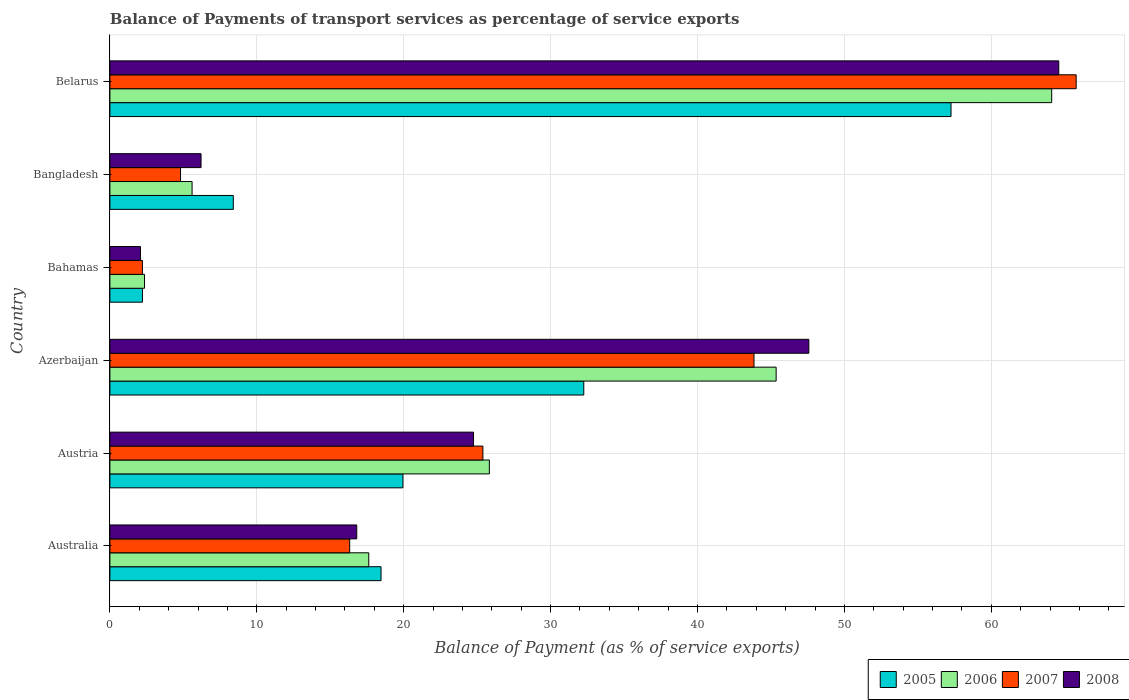How many different coloured bars are there?
Your answer should be compact. 4. How many groups of bars are there?
Ensure brevity in your answer.  6. Are the number of bars per tick equal to the number of legend labels?
Your answer should be compact. Yes. Are the number of bars on each tick of the Y-axis equal?
Your answer should be very brief. Yes. How many bars are there on the 5th tick from the top?
Make the answer very short. 4. How many bars are there on the 3rd tick from the bottom?
Make the answer very short. 4. What is the label of the 3rd group of bars from the top?
Your answer should be very brief. Bahamas. In how many cases, is the number of bars for a given country not equal to the number of legend labels?
Keep it short and to the point. 0. What is the balance of payments of transport services in 2008 in Azerbaijan?
Keep it short and to the point. 47.58. Across all countries, what is the maximum balance of payments of transport services in 2008?
Provide a succinct answer. 64.6. Across all countries, what is the minimum balance of payments of transport services in 2007?
Your answer should be very brief. 2.21. In which country was the balance of payments of transport services in 2008 maximum?
Ensure brevity in your answer.  Belarus. In which country was the balance of payments of transport services in 2006 minimum?
Your answer should be very brief. Bahamas. What is the total balance of payments of transport services in 2008 in the graph?
Provide a succinct answer. 162.02. What is the difference between the balance of payments of transport services in 2006 in Australia and that in Belarus?
Offer a very short reply. -46.49. What is the difference between the balance of payments of transport services in 2008 in Azerbaijan and the balance of payments of transport services in 2005 in Australia?
Your answer should be very brief. 29.12. What is the average balance of payments of transport services in 2008 per country?
Your answer should be compact. 27. What is the difference between the balance of payments of transport services in 2006 and balance of payments of transport services in 2007 in Bangladesh?
Offer a terse response. 0.79. In how many countries, is the balance of payments of transport services in 2005 greater than 60 %?
Offer a very short reply. 0. What is the ratio of the balance of payments of transport services in 2008 in Australia to that in Austria?
Provide a succinct answer. 0.68. What is the difference between the highest and the second highest balance of payments of transport services in 2007?
Give a very brief answer. 21.93. What is the difference between the highest and the lowest balance of payments of transport services in 2005?
Your response must be concise. 55.04. In how many countries, is the balance of payments of transport services in 2008 greater than the average balance of payments of transport services in 2008 taken over all countries?
Offer a very short reply. 2. Is the sum of the balance of payments of transport services in 2006 in Australia and Azerbaijan greater than the maximum balance of payments of transport services in 2005 across all countries?
Ensure brevity in your answer.  Yes. Is it the case that in every country, the sum of the balance of payments of transport services in 2005 and balance of payments of transport services in 2006 is greater than the sum of balance of payments of transport services in 2008 and balance of payments of transport services in 2007?
Your answer should be very brief. No. Is it the case that in every country, the sum of the balance of payments of transport services in 2006 and balance of payments of transport services in 2007 is greater than the balance of payments of transport services in 2008?
Offer a very short reply. Yes. How many bars are there?
Keep it short and to the point. 24. Are all the bars in the graph horizontal?
Your response must be concise. Yes. What is the difference between two consecutive major ticks on the X-axis?
Offer a very short reply. 10. Are the values on the major ticks of X-axis written in scientific E-notation?
Your answer should be very brief. No. Does the graph contain any zero values?
Give a very brief answer. No. Does the graph contain grids?
Your answer should be very brief. Yes. Where does the legend appear in the graph?
Give a very brief answer. Bottom right. What is the title of the graph?
Your answer should be compact. Balance of Payments of transport services as percentage of service exports. Does "1989" appear as one of the legend labels in the graph?
Offer a very short reply. No. What is the label or title of the X-axis?
Give a very brief answer. Balance of Payment (as % of service exports). What is the Balance of Payment (as % of service exports) in 2005 in Australia?
Your answer should be compact. 18.46. What is the Balance of Payment (as % of service exports) of 2006 in Australia?
Your response must be concise. 17.62. What is the Balance of Payment (as % of service exports) in 2007 in Australia?
Ensure brevity in your answer.  16.32. What is the Balance of Payment (as % of service exports) in 2008 in Australia?
Provide a succinct answer. 16.81. What is the Balance of Payment (as % of service exports) in 2005 in Austria?
Your answer should be compact. 19.95. What is the Balance of Payment (as % of service exports) in 2006 in Austria?
Provide a succinct answer. 25.83. What is the Balance of Payment (as % of service exports) in 2007 in Austria?
Provide a succinct answer. 25.39. What is the Balance of Payment (as % of service exports) of 2008 in Austria?
Keep it short and to the point. 24.75. What is the Balance of Payment (as % of service exports) of 2005 in Azerbaijan?
Provide a short and direct response. 32.26. What is the Balance of Payment (as % of service exports) of 2006 in Azerbaijan?
Give a very brief answer. 45.35. What is the Balance of Payment (as % of service exports) of 2007 in Azerbaijan?
Your answer should be very brief. 43.85. What is the Balance of Payment (as % of service exports) in 2008 in Azerbaijan?
Your answer should be compact. 47.58. What is the Balance of Payment (as % of service exports) of 2005 in Bahamas?
Your response must be concise. 2.22. What is the Balance of Payment (as % of service exports) in 2006 in Bahamas?
Give a very brief answer. 2.36. What is the Balance of Payment (as % of service exports) of 2007 in Bahamas?
Give a very brief answer. 2.21. What is the Balance of Payment (as % of service exports) of 2008 in Bahamas?
Provide a succinct answer. 2.08. What is the Balance of Payment (as % of service exports) of 2005 in Bangladesh?
Your answer should be compact. 8.4. What is the Balance of Payment (as % of service exports) of 2006 in Bangladesh?
Offer a terse response. 5.6. What is the Balance of Payment (as % of service exports) of 2007 in Bangladesh?
Your answer should be very brief. 4.81. What is the Balance of Payment (as % of service exports) of 2008 in Bangladesh?
Your response must be concise. 6.21. What is the Balance of Payment (as % of service exports) in 2005 in Belarus?
Offer a terse response. 57.26. What is the Balance of Payment (as % of service exports) of 2006 in Belarus?
Your answer should be compact. 64.11. What is the Balance of Payment (as % of service exports) of 2007 in Belarus?
Give a very brief answer. 65.78. What is the Balance of Payment (as % of service exports) in 2008 in Belarus?
Give a very brief answer. 64.6. Across all countries, what is the maximum Balance of Payment (as % of service exports) in 2005?
Offer a terse response. 57.26. Across all countries, what is the maximum Balance of Payment (as % of service exports) in 2006?
Your response must be concise. 64.11. Across all countries, what is the maximum Balance of Payment (as % of service exports) of 2007?
Your answer should be very brief. 65.78. Across all countries, what is the maximum Balance of Payment (as % of service exports) of 2008?
Give a very brief answer. 64.6. Across all countries, what is the minimum Balance of Payment (as % of service exports) in 2005?
Provide a succinct answer. 2.22. Across all countries, what is the minimum Balance of Payment (as % of service exports) of 2006?
Provide a short and direct response. 2.36. Across all countries, what is the minimum Balance of Payment (as % of service exports) of 2007?
Give a very brief answer. 2.21. Across all countries, what is the minimum Balance of Payment (as % of service exports) in 2008?
Keep it short and to the point. 2.08. What is the total Balance of Payment (as % of service exports) in 2005 in the graph?
Ensure brevity in your answer.  138.54. What is the total Balance of Payment (as % of service exports) of 2006 in the graph?
Offer a very short reply. 160.88. What is the total Balance of Payment (as % of service exports) of 2007 in the graph?
Offer a very short reply. 158.37. What is the total Balance of Payment (as % of service exports) of 2008 in the graph?
Keep it short and to the point. 162.02. What is the difference between the Balance of Payment (as % of service exports) of 2005 in Australia and that in Austria?
Your answer should be compact. -1.49. What is the difference between the Balance of Payment (as % of service exports) in 2006 in Australia and that in Austria?
Offer a terse response. -8.21. What is the difference between the Balance of Payment (as % of service exports) of 2007 in Australia and that in Austria?
Keep it short and to the point. -9.07. What is the difference between the Balance of Payment (as % of service exports) in 2008 in Australia and that in Austria?
Give a very brief answer. -7.95. What is the difference between the Balance of Payment (as % of service exports) in 2005 in Australia and that in Azerbaijan?
Your response must be concise. -13.8. What is the difference between the Balance of Payment (as % of service exports) in 2006 in Australia and that in Azerbaijan?
Give a very brief answer. -27.73. What is the difference between the Balance of Payment (as % of service exports) of 2007 in Australia and that in Azerbaijan?
Provide a succinct answer. -27.52. What is the difference between the Balance of Payment (as % of service exports) in 2008 in Australia and that in Azerbaijan?
Offer a terse response. -30.78. What is the difference between the Balance of Payment (as % of service exports) of 2005 in Australia and that in Bahamas?
Provide a succinct answer. 16.24. What is the difference between the Balance of Payment (as % of service exports) in 2006 in Australia and that in Bahamas?
Your answer should be very brief. 15.27. What is the difference between the Balance of Payment (as % of service exports) in 2007 in Australia and that in Bahamas?
Provide a succinct answer. 14.11. What is the difference between the Balance of Payment (as % of service exports) of 2008 in Australia and that in Bahamas?
Keep it short and to the point. 14.72. What is the difference between the Balance of Payment (as % of service exports) in 2005 in Australia and that in Bangladesh?
Give a very brief answer. 10.06. What is the difference between the Balance of Payment (as % of service exports) of 2006 in Australia and that in Bangladesh?
Your answer should be compact. 12.03. What is the difference between the Balance of Payment (as % of service exports) in 2007 in Australia and that in Bangladesh?
Offer a terse response. 11.52. What is the difference between the Balance of Payment (as % of service exports) in 2008 in Australia and that in Bangladesh?
Provide a succinct answer. 10.6. What is the difference between the Balance of Payment (as % of service exports) of 2005 in Australia and that in Belarus?
Give a very brief answer. -38.8. What is the difference between the Balance of Payment (as % of service exports) in 2006 in Australia and that in Belarus?
Provide a succinct answer. -46.49. What is the difference between the Balance of Payment (as % of service exports) of 2007 in Australia and that in Belarus?
Offer a terse response. -49.46. What is the difference between the Balance of Payment (as % of service exports) of 2008 in Australia and that in Belarus?
Keep it short and to the point. -47.79. What is the difference between the Balance of Payment (as % of service exports) in 2005 in Austria and that in Azerbaijan?
Your answer should be very brief. -12.31. What is the difference between the Balance of Payment (as % of service exports) in 2006 in Austria and that in Azerbaijan?
Your response must be concise. -19.52. What is the difference between the Balance of Payment (as % of service exports) in 2007 in Austria and that in Azerbaijan?
Make the answer very short. -18.45. What is the difference between the Balance of Payment (as % of service exports) in 2008 in Austria and that in Azerbaijan?
Your answer should be compact. -22.83. What is the difference between the Balance of Payment (as % of service exports) of 2005 in Austria and that in Bahamas?
Give a very brief answer. 17.73. What is the difference between the Balance of Payment (as % of service exports) of 2006 in Austria and that in Bahamas?
Your answer should be compact. 23.48. What is the difference between the Balance of Payment (as % of service exports) in 2007 in Austria and that in Bahamas?
Offer a very short reply. 23.18. What is the difference between the Balance of Payment (as % of service exports) of 2008 in Austria and that in Bahamas?
Keep it short and to the point. 22.67. What is the difference between the Balance of Payment (as % of service exports) in 2005 in Austria and that in Bangladesh?
Ensure brevity in your answer.  11.55. What is the difference between the Balance of Payment (as % of service exports) in 2006 in Austria and that in Bangladesh?
Give a very brief answer. 20.24. What is the difference between the Balance of Payment (as % of service exports) in 2007 in Austria and that in Bangladesh?
Your response must be concise. 20.58. What is the difference between the Balance of Payment (as % of service exports) in 2008 in Austria and that in Bangladesh?
Provide a short and direct response. 18.55. What is the difference between the Balance of Payment (as % of service exports) in 2005 in Austria and that in Belarus?
Your answer should be very brief. -37.31. What is the difference between the Balance of Payment (as % of service exports) in 2006 in Austria and that in Belarus?
Offer a very short reply. -38.28. What is the difference between the Balance of Payment (as % of service exports) of 2007 in Austria and that in Belarus?
Your answer should be very brief. -40.39. What is the difference between the Balance of Payment (as % of service exports) of 2008 in Austria and that in Belarus?
Provide a short and direct response. -39.84. What is the difference between the Balance of Payment (as % of service exports) of 2005 in Azerbaijan and that in Bahamas?
Your answer should be very brief. 30.04. What is the difference between the Balance of Payment (as % of service exports) of 2006 in Azerbaijan and that in Bahamas?
Keep it short and to the point. 43. What is the difference between the Balance of Payment (as % of service exports) of 2007 in Azerbaijan and that in Bahamas?
Provide a succinct answer. 41.63. What is the difference between the Balance of Payment (as % of service exports) in 2008 in Azerbaijan and that in Bahamas?
Make the answer very short. 45.5. What is the difference between the Balance of Payment (as % of service exports) of 2005 in Azerbaijan and that in Bangladesh?
Your answer should be very brief. 23.86. What is the difference between the Balance of Payment (as % of service exports) in 2006 in Azerbaijan and that in Bangladesh?
Ensure brevity in your answer.  39.76. What is the difference between the Balance of Payment (as % of service exports) in 2007 in Azerbaijan and that in Bangladesh?
Provide a succinct answer. 39.04. What is the difference between the Balance of Payment (as % of service exports) in 2008 in Azerbaijan and that in Bangladesh?
Provide a succinct answer. 41.38. What is the difference between the Balance of Payment (as % of service exports) of 2005 in Azerbaijan and that in Belarus?
Ensure brevity in your answer.  -25. What is the difference between the Balance of Payment (as % of service exports) in 2006 in Azerbaijan and that in Belarus?
Keep it short and to the point. -18.76. What is the difference between the Balance of Payment (as % of service exports) in 2007 in Azerbaijan and that in Belarus?
Offer a terse response. -21.93. What is the difference between the Balance of Payment (as % of service exports) of 2008 in Azerbaijan and that in Belarus?
Keep it short and to the point. -17.01. What is the difference between the Balance of Payment (as % of service exports) in 2005 in Bahamas and that in Bangladesh?
Ensure brevity in your answer.  -6.18. What is the difference between the Balance of Payment (as % of service exports) of 2006 in Bahamas and that in Bangladesh?
Your answer should be very brief. -3.24. What is the difference between the Balance of Payment (as % of service exports) of 2007 in Bahamas and that in Bangladesh?
Give a very brief answer. -2.59. What is the difference between the Balance of Payment (as % of service exports) of 2008 in Bahamas and that in Bangladesh?
Your response must be concise. -4.12. What is the difference between the Balance of Payment (as % of service exports) in 2005 in Bahamas and that in Belarus?
Offer a terse response. -55.04. What is the difference between the Balance of Payment (as % of service exports) in 2006 in Bahamas and that in Belarus?
Provide a short and direct response. -61.76. What is the difference between the Balance of Payment (as % of service exports) in 2007 in Bahamas and that in Belarus?
Provide a succinct answer. -63.57. What is the difference between the Balance of Payment (as % of service exports) of 2008 in Bahamas and that in Belarus?
Keep it short and to the point. -62.51. What is the difference between the Balance of Payment (as % of service exports) in 2005 in Bangladesh and that in Belarus?
Provide a short and direct response. -48.86. What is the difference between the Balance of Payment (as % of service exports) of 2006 in Bangladesh and that in Belarus?
Ensure brevity in your answer.  -58.52. What is the difference between the Balance of Payment (as % of service exports) of 2007 in Bangladesh and that in Belarus?
Provide a short and direct response. -60.97. What is the difference between the Balance of Payment (as % of service exports) of 2008 in Bangladesh and that in Belarus?
Make the answer very short. -58.39. What is the difference between the Balance of Payment (as % of service exports) in 2005 in Australia and the Balance of Payment (as % of service exports) in 2006 in Austria?
Your response must be concise. -7.37. What is the difference between the Balance of Payment (as % of service exports) in 2005 in Australia and the Balance of Payment (as % of service exports) in 2007 in Austria?
Give a very brief answer. -6.93. What is the difference between the Balance of Payment (as % of service exports) of 2005 in Australia and the Balance of Payment (as % of service exports) of 2008 in Austria?
Keep it short and to the point. -6.3. What is the difference between the Balance of Payment (as % of service exports) of 2006 in Australia and the Balance of Payment (as % of service exports) of 2007 in Austria?
Your answer should be compact. -7.77. What is the difference between the Balance of Payment (as % of service exports) in 2006 in Australia and the Balance of Payment (as % of service exports) in 2008 in Austria?
Provide a succinct answer. -7.13. What is the difference between the Balance of Payment (as % of service exports) of 2007 in Australia and the Balance of Payment (as % of service exports) of 2008 in Austria?
Your response must be concise. -8.43. What is the difference between the Balance of Payment (as % of service exports) of 2005 in Australia and the Balance of Payment (as % of service exports) of 2006 in Azerbaijan?
Keep it short and to the point. -26.9. What is the difference between the Balance of Payment (as % of service exports) of 2005 in Australia and the Balance of Payment (as % of service exports) of 2007 in Azerbaijan?
Offer a very short reply. -25.39. What is the difference between the Balance of Payment (as % of service exports) in 2005 in Australia and the Balance of Payment (as % of service exports) in 2008 in Azerbaijan?
Offer a very short reply. -29.12. What is the difference between the Balance of Payment (as % of service exports) in 2006 in Australia and the Balance of Payment (as % of service exports) in 2007 in Azerbaijan?
Provide a short and direct response. -26.22. What is the difference between the Balance of Payment (as % of service exports) of 2006 in Australia and the Balance of Payment (as % of service exports) of 2008 in Azerbaijan?
Your response must be concise. -29.96. What is the difference between the Balance of Payment (as % of service exports) of 2007 in Australia and the Balance of Payment (as % of service exports) of 2008 in Azerbaijan?
Ensure brevity in your answer.  -31.26. What is the difference between the Balance of Payment (as % of service exports) of 2005 in Australia and the Balance of Payment (as % of service exports) of 2006 in Bahamas?
Offer a terse response. 16.1. What is the difference between the Balance of Payment (as % of service exports) of 2005 in Australia and the Balance of Payment (as % of service exports) of 2007 in Bahamas?
Offer a very short reply. 16.24. What is the difference between the Balance of Payment (as % of service exports) of 2005 in Australia and the Balance of Payment (as % of service exports) of 2008 in Bahamas?
Offer a very short reply. 16.38. What is the difference between the Balance of Payment (as % of service exports) of 2006 in Australia and the Balance of Payment (as % of service exports) of 2007 in Bahamas?
Give a very brief answer. 15.41. What is the difference between the Balance of Payment (as % of service exports) of 2006 in Australia and the Balance of Payment (as % of service exports) of 2008 in Bahamas?
Your response must be concise. 15.54. What is the difference between the Balance of Payment (as % of service exports) of 2007 in Australia and the Balance of Payment (as % of service exports) of 2008 in Bahamas?
Provide a short and direct response. 14.24. What is the difference between the Balance of Payment (as % of service exports) of 2005 in Australia and the Balance of Payment (as % of service exports) of 2006 in Bangladesh?
Give a very brief answer. 12.86. What is the difference between the Balance of Payment (as % of service exports) of 2005 in Australia and the Balance of Payment (as % of service exports) of 2007 in Bangladesh?
Keep it short and to the point. 13.65. What is the difference between the Balance of Payment (as % of service exports) in 2005 in Australia and the Balance of Payment (as % of service exports) in 2008 in Bangladesh?
Your answer should be compact. 12.25. What is the difference between the Balance of Payment (as % of service exports) in 2006 in Australia and the Balance of Payment (as % of service exports) in 2007 in Bangladesh?
Your response must be concise. 12.82. What is the difference between the Balance of Payment (as % of service exports) in 2006 in Australia and the Balance of Payment (as % of service exports) in 2008 in Bangladesh?
Provide a short and direct response. 11.42. What is the difference between the Balance of Payment (as % of service exports) in 2007 in Australia and the Balance of Payment (as % of service exports) in 2008 in Bangladesh?
Keep it short and to the point. 10.12. What is the difference between the Balance of Payment (as % of service exports) of 2005 in Australia and the Balance of Payment (as % of service exports) of 2006 in Belarus?
Your answer should be compact. -45.66. What is the difference between the Balance of Payment (as % of service exports) of 2005 in Australia and the Balance of Payment (as % of service exports) of 2007 in Belarus?
Provide a short and direct response. -47.32. What is the difference between the Balance of Payment (as % of service exports) in 2005 in Australia and the Balance of Payment (as % of service exports) in 2008 in Belarus?
Provide a short and direct response. -46.14. What is the difference between the Balance of Payment (as % of service exports) in 2006 in Australia and the Balance of Payment (as % of service exports) in 2007 in Belarus?
Make the answer very short. -48.16. What is the difference between the Balance of Payment (as % of service exports) of 2006 in Australia and the Balance of Payment (as % of service exports) of 2008 in Belarus?
Make the answer very short. -46.97. What is the difference between the Balance of Payment (as % of service exports) of 2007 in Australia and the Balance of Payment (as % of service exports) of 2008 in Belarus?
Give a very brief answer. -48.27. What is the difference between the Balance of Payment (as % of service exports) of 2005 in Austria and the Balance of Payment (as % of service exports) of 2006 in Azerbaijan?
Provide a succinct answer. -25.41. What is the difference between the Balance of Payment (as % of service exports) in 2005 in Austria and the Balance of Payment (as % of service exports) in 2007 in Azerbaijan?
Provide a succinct answer. -23.9. What is the difference between the Balance of Payment (as % of service exports) of 2005 in Austria and the Balance of Payment (as % of service exports) of 2008 in Azerbaijan?
Offer a very short reply. -27.63. What is the difference between the Balance of Payment (as % of service exports) of 2006 in Austria and the Balance of Payment (as % of service exports) of 2007 in Azerbaijan?
Your answer should be compact. -18.02. What is the difference between the Balance of Payment (as % of service exports) of 2006 in Austria and the Balance of Payment (as % of service exports) of 2008 in Azerbaijan?
Your answer should be very brief. -21.75. What is the difference between the Balance of Payment (as % of service exports) of 2007 in Austria and the Balance of Payment (as % of service exports) of 2008 in Azerbaijan?
Your response must be concise. -22.19. What is the difference between the Balance of Payment (as % of service exports) in 2005 in Austria and the Balance of Payment (as % of service exports) in 2006 in Bahamas?
Make the answer very short. 17.59. What is the difference between the Balance of Payment (as % of service exports) of 2005 in Austria and the Balance of Payment (as % of service exports) of 2007 in Bahamas?
Your response must be concise. 17.74. What is the difference between the Balance of Payment (as % of service exports) in 2005 in Austria and the Balance of Payment (as % of service exports) in 2008 in Bahamas?
Your answer should be very brief. 17.87. What is the difference between the Balance of Payment (as % of service exports) in 2006 in Austria and the Balance of Payment (as % of service exports) in 2007 in Bahamas?
Offer a very short reply. 23.62. What is the difference between the Balance of Payment (as % of service exports) in 2006 in Austria and the Balance of Payment (as % of service exports) in 2008 in Bahamas?
Your answer should be compact. 23.75. What is the difference between the Balance of Payment (as % of service exports) of 2007 in Austria and the Balance of Payment (as % of service exports) of 2008 in Bahamas?
Give a very brief answer. 23.31. What is the difference between the Balance of Payment (as % of service exports) in 2005 in Austria and the Balance of Payment (as % of service exports) in 2006 in Bangladesh?
Keep it short and to the point. 14.35. What is the difference between the Balance of Payment (as % of service exports) in 2005 in Austria and the Balance of Payment (as % of service exports) in 2007 in Bangladesh?
Keep it short and to the point. 15.14. What is the difference between the Balance of Payment (as % of service exports) of 2005 in Austria and the Balance of Payment (as % of service exports) of 2008 in Bangladesh?
Make the answer very short. 13.74. What is the difference between the Balance of Payment (as % of service exports) of 2006 in Austria and the Balance of Payment (as % of service exports) of 2007 in Bangladesh?
Ensure brevity in your answer.  21.02. What is the difference between the Balance of Payment (as % of service exports) of 2006 in Austria and the Balance of Payment (as % of service exports) of 2008 in Bangladesh?
Offer a very short reply. 19.63. What is the difference between the Balance of Payment (as % of service exports) of 2007 in Austria and the Balance of Payment (as % of service exports) of 2008 in Bangladesh?
Your answer should be very brief. 19.19. What is the difference between the Balance of Payment (as % of service exports) of 2005 in Austria and the Balance of Payment (as % of service exports) of 2006 in Belarus?
Make the answer very short. -44.17. What is the difference between the Balance of Payment (as % of service exports) of 2005 in Austria and the Balance of Payment (as % of service exports) of 2007 in Belarus?
Provide a succinct answer. -45.83. What is the difference between the Balance of Payment (as % of service exports) in 2005 in Austria and the Balance of Payment (as % of service exports) in 2008 in Belarus?
Give a very brief answer. -44.65. What is the difference between the Balance of Payment (as % of service exports) of 2006 in Austria and the Balance of Payment (as % of service exports) of 2007 in Belarus?
Your response must be concise. -39.95. What is the difference between the Balance of Payment (as % of service exports) of 2006 in Austria and the Balance of Payment (as % of service exports) of 2008 in Belarus?
Provide a succinct answer. -38.76. What is the difference between the Balance of Payment (as % of service exports) of 2007 in Austria and the Balance of Payment (as % of service exports) of 2008 in Belarus?
Your answer should be compact. -39.2. What is the difference between the Balance of Payment (as % of service exports) in 2005 in Azerbaijan and the Balance of Payment (as % of service exports) in 2006 in Bahamas?
Offer a very short reply. 29.9. What is the difference between the Balance of Payment (as % of service exports) in 2005 in Azerbaijan and the Balance of Payment (as % of service exports) in 2007 in Bahamas?
Provide a short and direct response. 30.05. What is the difference between the Balance of Payment (as % of service exports) of 2005 in Azerbaijan and the Balance of Payment (as % of service exports) of 2008 in Bahamas?
Offer a terse response. 30.18. What is the difference between the Balance of Payment (as % of service exports) in 2006 in Azerbaijan and the Balance of Payment (as % of service exports) in 2007 in Bahamas?
Your response must be concise. 43.14. What is the difference between the Balance of Payment (as % of service exports) of 2006 in Azerbaijan and the Balance of Payment (as % of service exports) of 2008 in Bahamas?
Provide a short and direct response. 43.27. What is the difference between the Balance of Payment (as % of service exports) in 2007 in Azerbaijan and the Balance of Payment (as % of service exports) in 2008 in Bahamas?
Keep it short and to the point. 41.77. What is the difference between the Balance of Payment (as % of service exports) of 2005 in Azerbaijan and the Balance of Payment (as % of service exports) of 2006 in Bangladesh?
Provide a short and direct response. 26.66. What is the difference between the Balance of Payment (as % of service exports) in 2005 in Azerbaijan and the Balance of Payment (as % of service exports) in 2007 in Bangladesh?
Offer a terse response. 27.45. What is the difference between the Balance of Payment (as % of service exports) of 2005 in Azerbaijan and the Balance of Payment (as % of service exports) of 2008 in Bangladesh?
Offer a terse response. 26.06. What is the difference between the Balance of Payment (as % of service exports) of 2006 in Azerbaijan and the Balance of Payment (as % of service exports) of 2007 in Bangladesh?
Make the answer very short. 40.55. What is the difference between the Balance of Payment (as % of service exports) in 2006 in Azerbaijan and the Balance of Payment (as % of service exports) in 2008 in Bangladesh?
Make the answer very short. 39.15. What is the difference between the Balance of Payment (as % of service exports) of 2007 in Azerbaijan and the Balance of Payment (as % of service exports) of 2008 in Bangladesh?
Offer a terse response. 37.64. What is the difference between the Balance of Payment (as % of service exports) in 2005 in Azerbaijan and the Balance of Payment (as % of service exports) in 2006 in Belarus?
Ensure brevity in your answer.  -31.85. What is the difference between the Balance of Payment (as % of service exports) in 2005 in Azerbaijan and the Balance of Payment (as % of service exports) in 2007 in Belarus?
Provide a succinct answer. -33.52. What is the difference between the Balance of Payment (as % of service exports) in 2005 in Azerbaijan and the Balance of Payment (as % of service exports) in 2008 in Belarus?
Ensure brevity in your answer.  -32.34. What is the difference between the Balance of Payment (as % of service exports) in 2006 in Azerbaijan and the Balance of Payment (as % of service exports) in 2007 in Belarus?
Offer a very short reply. -20.43. What is the difference between the Balance of Payment (as % of service exports) in 2006 in Azerbaijan and the Balance of Payment (as % of service exports) in 2008 in Belarus?
Provide a short and direct response. -19.24. What is the difference between the Balance of Payment (as % of service exports) in 2007 in Azerbaijan and the Balance of Payment (as % of service exports) in 2008 in Belarus?
Your response must be concise. -20.75. What is the difference between the Balance of Payment (as % of service exports) in 2005 in Bahamas and the Balance of Payment (as % of service exports) in 2006 in Bangladesh?
Ensure brevity in your answer.  -3.38. What is the difference between the Balance of Payment (as % of service exports) in 2005 in Bahamas and the Balance of Payment (as % of service exports) in 2007 in Bangladesh?
Make the answer very short. -2.59. What is the difference between the Balance of Payment (as % of service exports) of 2005 in Bahamas and the Balance of Payment (as % of service exports) of 2008 in Bangladesh?
Your answer should be compact. -3.99. What is the difference between the Balance of Payment (as % of service exports) in 2006 in Bahamas and the Balance of Payment (as % of service exports) in 2007 in Bangladesh?
Provide a short and direct response. -2.45. What is the difference between the Balance of Payment (as % of service exports) in 2006 in Bahamas and the Balance of Payment (as % of service exports) in 2008 in Bangladesh?
Your response must be concise. -3.85. What is the difference between the Balance of Payment (as % of service exports) in 2007 in Bahamas and the Balance of Payment (as % of service exports) in 2008 in Bangladesh?
Your answer should be very brief. -3.99. What is the difference between the Balance of Payment (as % of service exports) of 2005 in Bahamas and the Balance of Payment (as % of service exports) of 2006 in Belarus?
Provide a short and direct response. -61.9. What is the difference between the Balance of Payment (as % of service exports) of 2005 in Bahamas and the Balance of Payment (as % of service exports) of 2007 in Belarus?
Provide a short and direct response. -63.56. What is the difference between the Balance of Payment (as % of service exports) of 2005 in Bahamas and the Balance of Payment (as % of service exports) of 2008 in Belarus?
Provide a succinct answer. -62.38. What is the difference between the Balance of Payment (as % of service exports) in 2006 in Bahamas and the Balance of Payment (as % of service exports) in 2007 in Belarus?
Ensure brevity in your answer.  -63.42. What is the difference between the Balance of Payment (as % of service exports) in 2006 in Bahamas and the Balance of Payment (as % of service exports) in 2008 in Belarus?
Give a very brief answer. -62.24. What is the difference between the Balance of Payment (as % of service exports) in 2007 in Bahamas and the Balance of Payment (as % of service exports) in 2008 in Belarus?
Your answer should be compact. -62.38. What is the difference between the Balance of Payment (as % of service exports) in 2005 in Bangladesh and the Balance of Payment (as % of service exports) in 2006 in Belarus?
Provide a succinct answer. -55.71. What is the difference between the Balance of Payment (as % of service exports) of 2005 in Bangladesh and the Balance of Payment (as % of service exports) of 2007 in Belarus?
Offer a very short reply. -57.38. What is the difference between the Balance of Payment (as % of service exports) in 2005 in Bangladesh and the Balance of Payment (as % of service exports) in 2008 in Belarus?
Provide a succinct answer. -56.19. What is the difference between the Balance of Payment (as % of service exports) of 2006 in Bangladesh and the Balance of Payment (as % of service exports) of 2007 in Belarus?
Offer a terse response. -60.18. What is the difference between the Balance of Payment (as % of service exports) in 2006 in Bangladesh and the Balance of Payment (as % of service exports) in 2008 in Belarus?
Your answer should be very brief. -59. What is the difference between the Balance of Payment (as % of service exports) in 2007 in Bangladesh and the Balance of Payment (as % of service exports) in 2008 in Belarus?
Offer a very short reply. -59.79. What is the average Balance of Payment (as % of service exports) in 2005 per country?
Keep it short and to the point. 23.09. What is the average Balance of Payment (as % of service exports) in 2006 per country?
Provide a succinct answer. 26.81. What is the average Balance of Payment (as % of service exports) of 2007 per country?
Offer a very short reply. 26.39. What is the average Balance of Payment (as % of service exports) of 2008 per country?
Give a very brief answer. 27. What is the difference between the Balance of Payment (as % of service exports) in 2005 and Balance of Payment (as % of service exports) in 2006 in Australia?
Your response must be concise. 0.83. What is the difference between the Balance of Payment (as % of service exports) of 2005 and Balance of Payment (as % of service exports) of 2007 in Australia?
Provide a short and direct response. 2.13. What is the difference between the Balance of Payment (as % of service exports) in 2005 and Balance of Payment (as % of service exports) in 2008 in Australia?
Your response must be concise. 1.65. What is the difference between the Balance of Payment (as % of service exports) of 2006 and Balance of Payment (as % of service exports) of 2007 in Australia?
Your answer should be very brief. 1.3. What is the difference between the Balance of Payment (as % of service exports) of 2006 and Balance of Payment (as % of service exports) of 2008 in Australia?
Your answer should be compact. 0.82. What is the difference between the Balance of Payment (as % of service exports) of 2007 and Balance of Payment (as % of service exports) of 2008 in Australia?
Your answer should be very brief. -0.48. What is the difference between the Balance of Payment (as % of service exports) of 2005 and Balance of Payment (as % of service exports) of 2006 in Austria?
Make the answer very short. -5.88. What is the difference between the Balance of Payment (as % of service exports) of 2005 and Balance of Payment (as % of service exports) of 2007 in Austria?
Offer a very short reply. -5.44. What is the difference between the Balance of Payment (as % of service exports) of 2005 and Balance of Payment (as % of service exports) of 2008 in Austria?
Provide a succinct answer. -4.81. What is the difference between the Balance of Payment (as % of service exports) of 2006 and Balance of Payment (as % of service exports) of 2007 in Austria?
Offer a terse response. 0.44. What is the difference between the Balance of Payment (as % of service exports) of 2006 and Balance of Payment (as % of service exports) of 2008 in Austria?
Make the answer very short. 1.08. What is the difference between the Balance of Payment (as % of service exports) in 2007 and Balance of Payment (as % of service exports) in 2008 in Austria?
Provide a succinct answer. 0.64. What is the difference between the Balance of Payment (as % of service exports) of 2005 and Balance of Payment (as % of service exports) of 2006 in Azerbaijan?
Offer a very short reply. -13.09. What is the difference between the Balance of Payment (as % of service exports) in 2005 and Balance of Payment (as % of service exports) in 2007 in Azerbaijan?
Provide a short and direct response. -11.59. What is the difference between the Balance of Payment (as % of service exports) of 2005 and Balance of Payment (as % of service exports) of 2008 in Azerbaijan?
Your answer should be compact. -15.32. What is the difference between the Balance of Payment (as % of service exports) of 2006 and Balance of Payment (as % of service exports) of 2007 in Azerbaijan?
Provide a short and direct response. 1.51. What is the difference between the Balance of Payment (as % of service exports) in 2006 and Balance of Payment (as % of service exports) in 2008 in Azerbaijan?
Your answer should be very brief. -2.23. What is the difference between the Balance of Payment (as % of service exports) of 2007 and Balance of Payment (as % of service exports) of 2008 in Azerbaijan?
Provide a succinct answer. -3.73. What is the difference between the Balance of Payment (as % of service exports) in 2005 and Balance of Payment (as % of service exports) in 2006 in Bahamas?
Offer a very short reply. -0.14. What is the difference between the Balance of Payment (as % of service exports) of 2005 and Balance of Payment (as % of service exports) of 2007 in Bahamas?
Provide a short and direct response. 0. What is the difference between the Balance of Payment (as % of service exports) of 2005 and Balance of Payment (as % of service exports) of 2008 in Bahamas?
Give a very brief answer. 0.14. What is the difference between the Balance of Payment (as % of service exports) in 2006 and Balance of Payment (as % of service exports) in 2007 in Bahamas?
Offer a terse response. 0.14. What is the difference between the Balance of Payment (as % of service exports) in 2006 and Balance of Payment (as % of service exports) in 2008 in Bahamas?
Your answer should be compact. 0.28. What is the difference between the Balance of Payment (as % of service exports) of 2007 and Balance of Payment (as % of service exports) of 2008 in Bahamas?
Ensure brevity in your answer.  0.13. What is the difference between the Balance of Payment (as % of service exports) of 2005 and Balance of Payment (as % of service exports) of 2006 in Bangladesh?
Make the answer very short. 2.81. What is the difference between the Balance of Payment (as % of service exports) of 2005 and Balance of Payment (as % of service exports) of 2007 in Bangladesh?
Provide a short and direct response. 3.59. What is the difference between the Balance of Payment (as % of service exports) of 2005 and Balance of Payment (as % of service exports) of 2008 in Bangladesh?
Ensure brevity in your answer.  2.2. What is the difference between the Balance of Payment (as % of service exports) in 2006 and Balance of Payment (as % of service exports) in 2007 in Bangladesh?
Offer a terse response. 0.79. What is the difference between the Balance of Payment (as % of service exports) of 2006 and Balance of Payment (as % of service exports) of 2008 in Bangladesh?
Make the answer very short. -0.61. What is the difference between the Balance of Payment (as % of service exports) of 2007 and Balance of Payment (as % of service exports) of 2008 in Bangladesh?
Give a very brief answer. -1.4. What is the difference between the Balance of Payment (as % of service exports) in 2005 and Balance of Payment (as % of service exports) in 2006 in Belarus?
Provide a succinct answer. -6.85. What is the difference between the Balance of Payment (as % of service exports) of 2005 and Balance of Payment (as % of service exports) of 2007 in Belarus?
Offer a terse response. -8.52. What is the difference between the Balance of Payment (as % of service exports) in 2005 and Balance of Payment (as % of service exports) in 2008 in Belarus?
Make the answer very short. -7.34. What is the difference between the Balance of Payment (as % of service exports) in 2006 and Balance of Payment (as % of service exports) in 2007 in Belarus?
Keep it short and to the point. -1.67. What is the difference between the Balance of Payment (as % of service exports) in 2006 and Balance of Payment (as % of service exports) in 2008 in Belarus?
Make the answer very short. -0.48. What is the difference between the Balance of Payment (as % of service exports) of 2007 and Balance of Payment (as % of service exports) of 2008 in Belarus?
Your response must be concise. 1.18. What is the ratio of the Balance of Payment (as % of service exports) of 2005 in Australia to that in Austria?
Offer a very short reply. 0.93. What is the ratio of the Balance of Payment (as % of service exports) in 2006 in Australia to that in Austria?
Provide a succinct answer. 0.68. What is the ratio of the Balance of Payment (as % of service exports) in 2007 in Australia to that in Austria?
Offer a terse response. 0.64. What is the ratio of the Balance of Payment (as % of service exports) in 2008 in Australia to that in Austria?
Provide a short and direct response. 0.68. What is the ratio of the Balance of Payment (as % of service exports) of 2005 in Australia to that in Azerbaijan?
Your response must be concise. 0.57. What is the ratio of the Balance of Payment (as % of service exports) in 2006 in Australia to that in Azerbaijan?
Provide a succinct answer. 0.39. What is the ratio of the Balance of Payment (as % of service exports) of 2007 in Australia to that in Azerbaijan?
Make the answer very short. 0.37. What is the ratio of the Balance of Payment (as % of service exports) of 2008 in Australia to that in Azerbaijan?
Ensure brevity in your answer.  0.35. What is the ratio of the Balance of Payment (as % of service exports) of 2005 in Australia to that in Bahamas?
Give a very brief answer. 8.33. What is the ratio of the Balance of Payment (as % of service exports) in 2006 in Australia to that in Bahamas?
Make the answer very short. 7.48. What is the ratio of the Balance of Payment (as % of service exports) of 2007 in Australia to that in Bahamas?
Offer a very short reply. 7.38. What is the ratio of the Balance of Payment (as % of service exports) of 2008 in Australia to that in Bahamas?
Your response must be concise. 8.08. What is the ratio of the Balance of Payment (as % of service exports) of 2005 in Australia to that in Bangladesh?
Keep it short and to the point. 2.2. What is the ratio of the Balance of Payment (as % of service exports) in 2006 in Australia to that in Bangladesh?
Offer a terse response. 3.15. What is the ratio of the Balance of Payment (as % of service exports) in 2007 in Australia to that in Bangladesh?
Provide a short and direct response. 3.4. What is the ratio of the Balance of Payment (as % of service exports) of 2008 in Australia to that in Bangladesh?
Provide a short and direct response. 2.71. What is the ratio of the Balance of Payment (as % of service exports) in 2005 in Australia to that in Belarus?
Keep it short and to the point. 0.32. What is the ratio of the Balance of Payment (as % of service exports) in 2006 in Australia to that in Belarus?
Provide a short and direct response. 0.27. What is the ratio of the Balance of Payment (as % of service exports) of 2007 in Australia to that in Belarus?
Ensure brevity in your answer.  0.25. What is the ratio of the Balance of Payment (as % of service exports) of 2008 in Australia to that in Belarus?
Ensure brevity in your answer.  0.26. What is the ratio of the Balance of Payment (as % of service exports) of 2005 in Austria to that in Azerbaijan?
Give a very brief answer. 0.62. What is the ratio of the Balance of Payment (as % of service exports) in 2006 in Austria to that in Azerbaijan?
Give a very brief answer. 0.57. What is the ratio of the Balance of Payment (as % of service exports) in 2007 in Austria to that in Azerbaijan?
Your answer should be compact. 0.58. What is the ratio of the Balance of Payment (as % of service exports) of 2008 in Austria to that in Azerbaijan?
Your answer should be compact. 0.52. What is the ratio of the Balance of Payment (as % of service exports) of 2005 in Austria to that in Bahamas?
Make the answer very short. 9. What is the ratio of the Balance of Payment (as % of service exports) of 2006 in Austria to that in Bahamas?
Make the answer very short. 10.96. What is the ratio of the Balance of Payment (as % of service exports) in 2007 in Austria to that in Bahamas?
Ensure brevity in your answer.  11.47. What is the ratio of the Balance of Payment (as % of service exports) in 2008 in Austria to that in Bahamas?
Ensure brevity in your answer.  11.9. What is the ratio of the Balance of Payment (as % of service exports) of 2005 in Austria to that in Bangladesh?
Offer a terse response. 2.37. What is the ratio of the Balance of Payment (as % of service exports) of 2006 in Austria to that in Bangladesh?
Offer a terse response. 4.62. What is the ratio of the Balance of Payment (as % of service exports) in 2007 in Austria to that in Bangladesh?
Give a very brief answer. 5.28. What is the ratio of the Balance of Payment (as % of service exports) in 2008 in Austria to that in Bangladesh?
Make the answer very short. 3.99. What is the ratio of the Balance of Payment (as % of service exports) of 2005 in Austria to that in Belarus?
Provide a succinct answer. 0.35. What is the ratio of the Balance of Payment (as % of service exports) in 2006 in Austria to that in Belarus?
Offer a terse response. 0.4. What is the ratio of the Balance of Payment (as % of service exports) in 2007 in Austria to that in Belarus?
Your response must be concise. 0.39. What is the ratio of the Balance of Payment (as % of service exports) in 2008 in Austria to that in Belarus?
Give a very brief answer. 0.38. What is the ratio of the Balance of Payment (as % of service exports) of 2005 in Azerbaijan to that in Bahamas?
Keep it short and to the point. 14.56. What is the ratio of the Balance of Payment (as % of service exports) in 2006 in Azerbaijan to that in Bahamas?
Ensure brevity in your answer.  19.25. What is the ratio of the Balance of Payment (as % of service exports) of 2007 in Azerbaijan to that in Bahamas?
Offer a terse response. 19.81. What is the ratio of the Balance of Payment (as % of service exports) of 2008 in Azerbaijan to that in Bahamas?
Ensure brevity in your answer.  22.87. What is the ratio of the Balance of Payment (as % of service exports) of 2005 in Azerbaijan to that in Bangladesh?
Ensure brevity in your answer.  3.84. What is the ratio of the Balance of Payment (as % of service exports) of 2006 in Azerbaijan to that in Bangladesh?
Your answer should be compact. 8.11. What is the ratio of the Balance of Payment (as % of service exports) of 2007 in Azerbaijan to that in Bangladesh?
Offer a very short reply. 9.12. What is the ratio of the Balance of Payment (as % of service exports) in 2008 in Azerbaijan to that in Bangladesh?
Your response must be concise. 7.67. What is the ratio of the Balance of Payment (as % of service exports) of 2005 in Azerbaijan to that in Belarus?
Your response must be concise. 0.56. What is the ratio of the Balance of Payment (as % of service exports) in 2006 in Azerbaijan to that in Belarus?
Provide a short and direct response. 0.71. What is the ratio of the Balance of Payment (as % of service exports) of 2007 in Azerbaijan to that in Belarus?
Offer a very short reply. 0.67. What is the ratio of the Balance of Payment (as % of service exports) of 2008 in Azerbaijan to that in Belarus?
Make the answer very short. 0.74. What is the ratio of the Balance of Payment (as % of service exports) in 2005 in Bahamas to that in Bangladesh?
Your answer should be compact. 0.26. What is the ratio of the Balance of Payment (as % of service exports) in 2006 in Bahamas to that in Bangladesh?
Offer a very short reply. 0.42. What is the ratio of the Balance of Payment (as % of service exports) in 2007 in Bahamas to that in Bangladesh?
Make the answer very short. 0.46. What is the ratio of the Balance of Payment (as % of service exports) in 2008 in Bahamas to that in Bangladesh?
Keep it short and to the point. 0.34. What is the ratio of the Balance of Payment (as % of service exports) of 2005 in Bahamas to that in Belarus?
Give a very brief answer. 0.04. What is the ratio of the Balance of Payment (as % of service exports) of 2006 in Bahamas to that in Belarus?
Make the answer very short. 0.04. What is the ratio of the Balance of Payment (as % of service exports) in 2007 in Bahamas to that in Belarus?
Ensure brevity in your answer.  0.03. What is the ratio of the Balance of Payment (as % of service exports) of 2008 in Bahamas to that in Belarus?
Your answer should be very brief. 0.03. What is the ratio of the Balance of Payment (as % of service exports) in 2005 in Bangladesh to that in Belarus?
Keep it short and to the point. 0.15. What is the ratio of the Balance of Payment (as % of service exports) in 2006 in Bangladesh to that in Belarus?
Your answer should be compact. 0.09. What is the ratio of the Balance of Payment (as % of service exports) in 2007 in Bangladesh to that in Belarus?
Offer a very short reply. 0.07. What is the ratio of the Balance of Payment (as % of service exports) in 2008 in Bangladesh to that in Belarus?
Provide a succinct answer. 0.1. What is the difference between the highest and the second highest Balance of Payment (as % of service exports) in 2005?
Give a very brief answer. 25. What is the difference between the highest and the second highest Balance of Payment (as % of service exports) in 2006?
Ensure brevity in your answer.  18.76. What is the difference between the highest and the second highest Balance of Payment (as % of service exports) of 2007?
Ensure brevity in your answer.  21.93. What is the difference between the highest and the second highest Balance of Payment (as % of service exports) of 2008?
Offer a terse response. 17.01. What is the difference between the highest and the lowest Balance of Payment (as % of service exports) in 2005?
Ensure brevity in your answer.  55.04. What is the difference between the highest and the lowest Balance of Payment (as % of service exports) in 2006?
Offer a terse response. 61.76. What is the difference between the highest and the lowest Balance of Payment (as % of service exports) in 2007?
Offer a very short reply. 63.57. What is the difference between the highest and the lowest Balance of Payment (as % of service exports) in 2008?
Give a very brief answer. 62.51. 